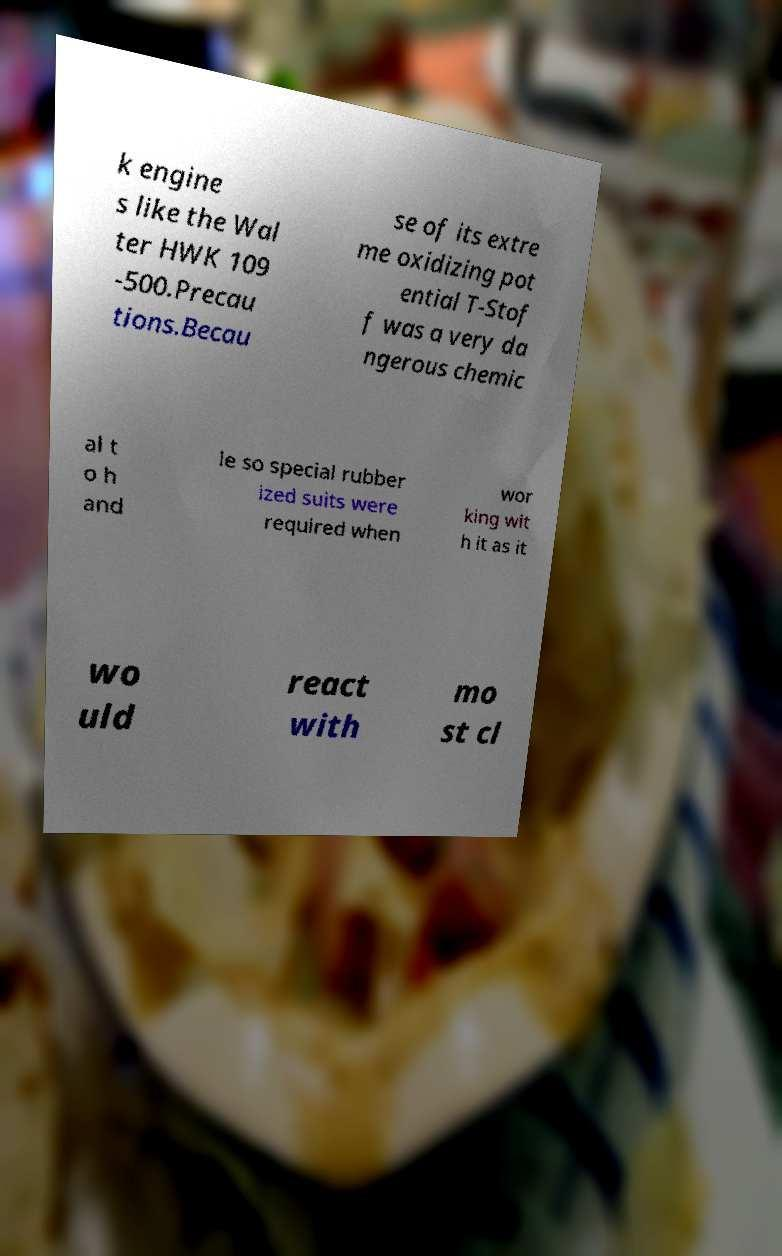Please read and relay the text visible in this image. What does it say? k engine s like the Wal ter HWK 109 -500.Precau tions.Becau se of its extre me oxidizing pot ential T-Stof f was a very da ngerous chemic al t o h and le so special rubber ized suits were required when wor king wit h it as it wo uld react with mo st cl 